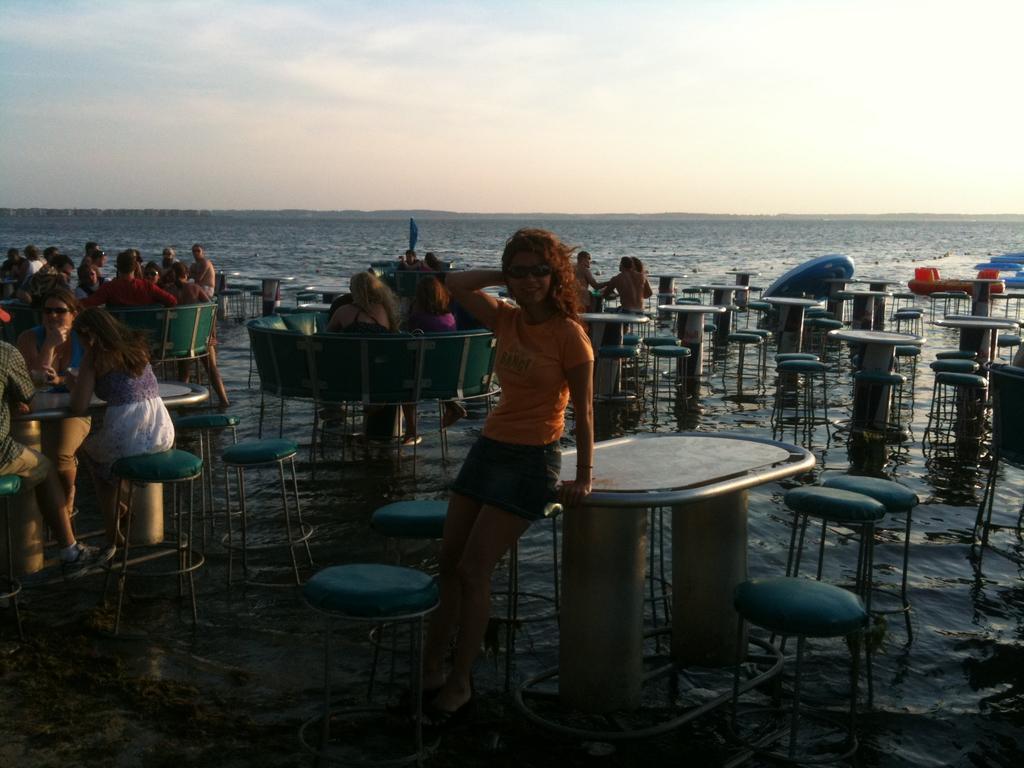Describe this image in one or two sentences. In this picture there are many people sitting on the tables and the picture is clicked inside a sea. There are few unoccupied tabled to the right side of the picture. A girl is posing for a picture in the center. 